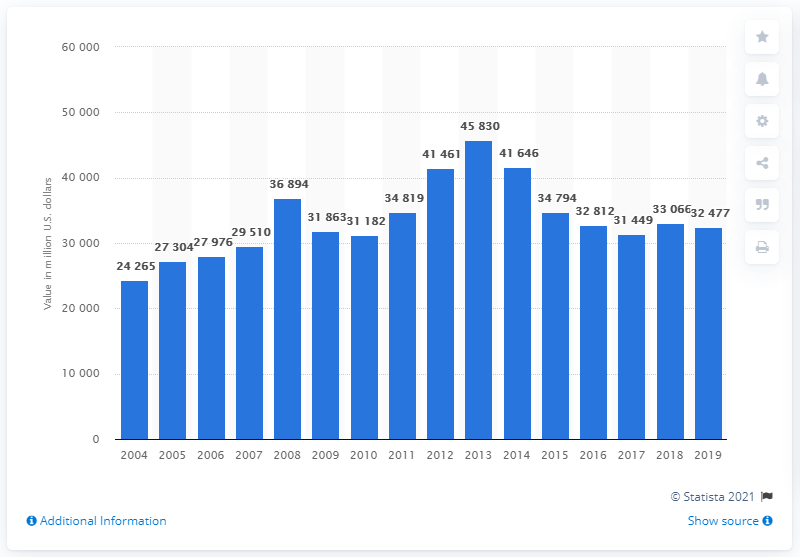Specify some key components in this picture. In 2019, the value of agricultural chemical shipments in the United States was approximately 32,477. 